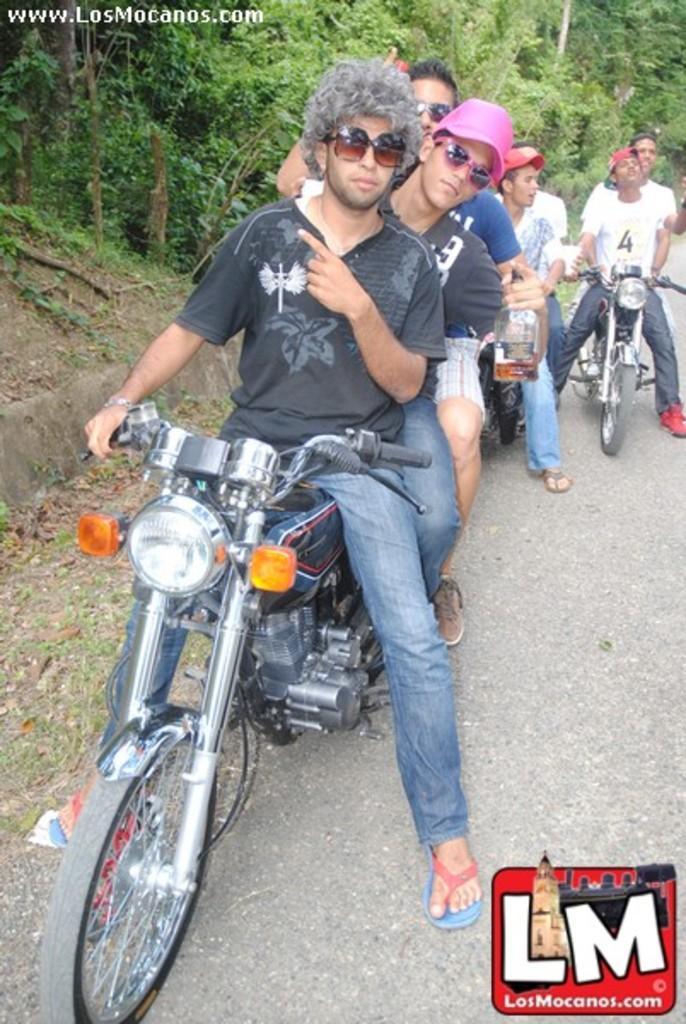In one or two sentences, can you explain what this image depicts? These group of people are sitting on motorbikes. Front this man wore black t-shirt and goggle. Backside of this person other man is holding a bottle. Far there are number of trees. 